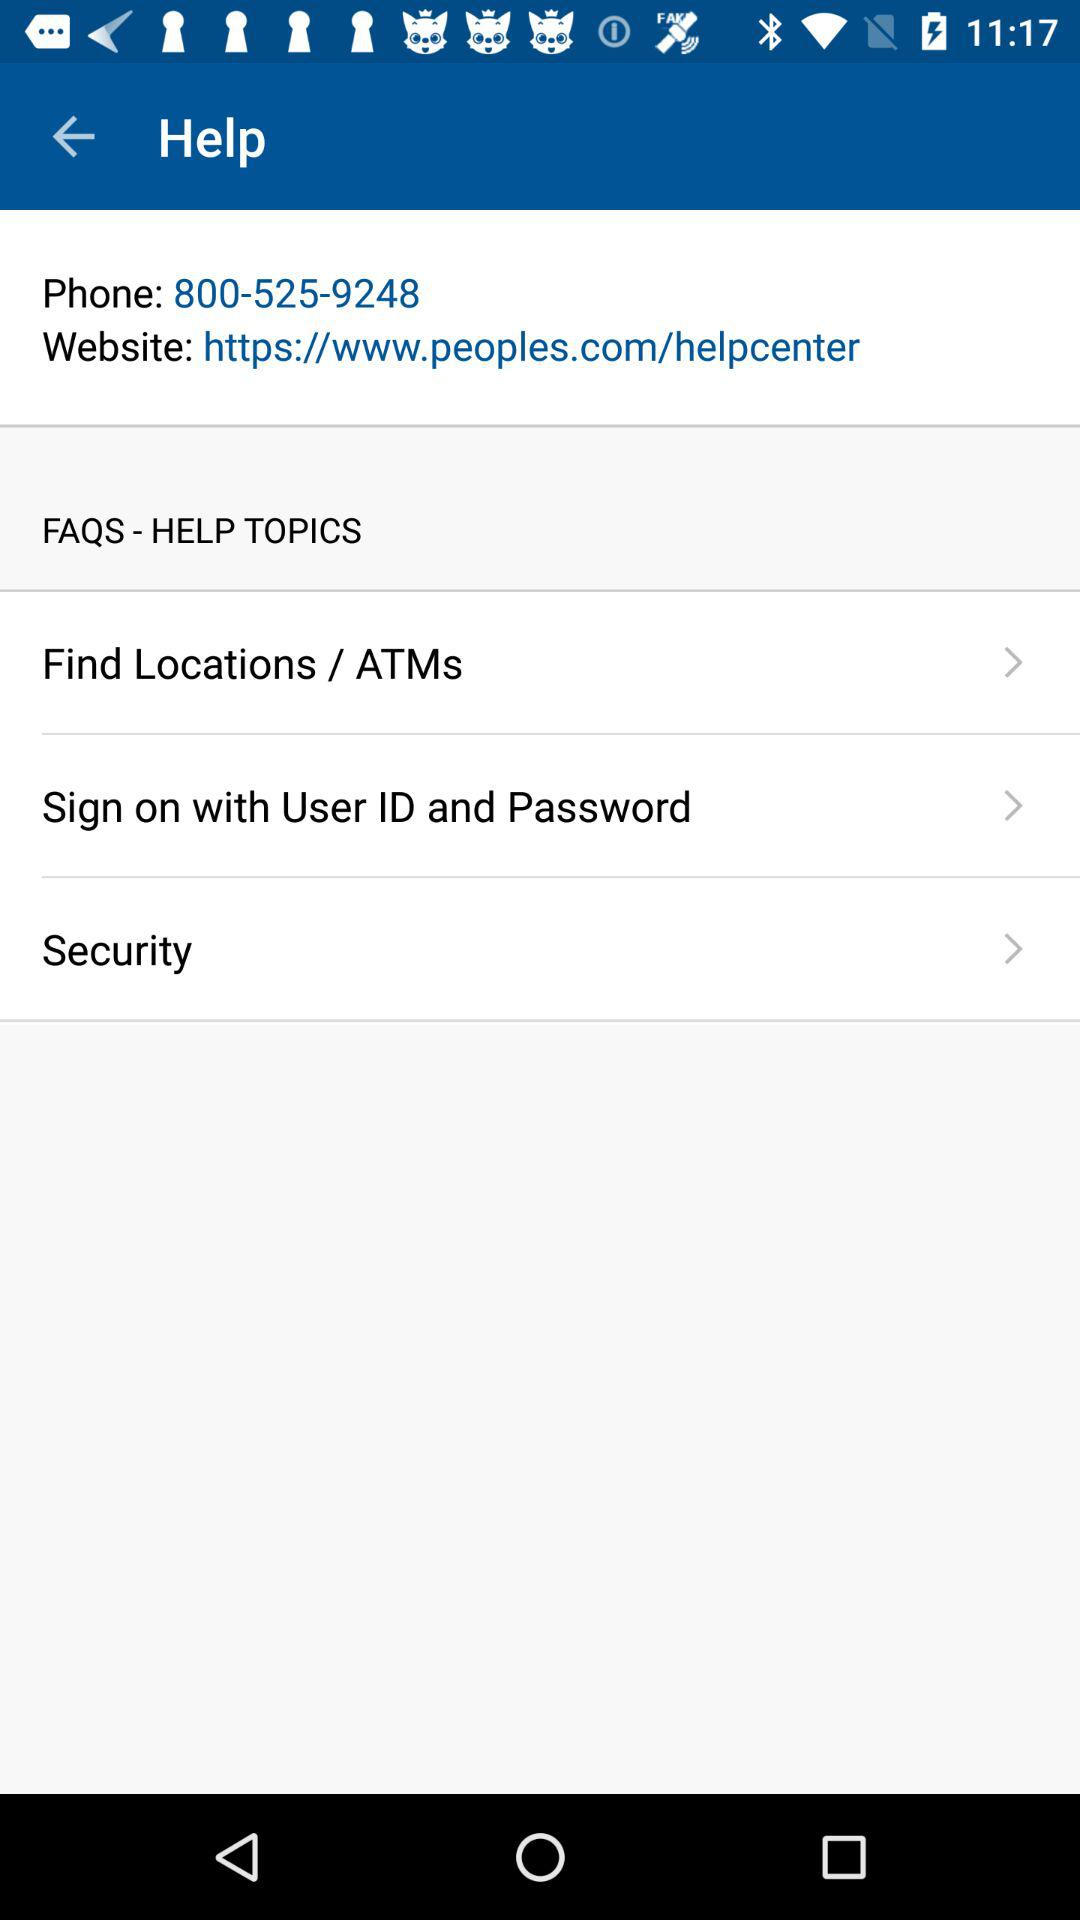What is the website? The website is https://www.peoples.com/helpcenter. 